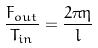<formula> <loc_0><loc_0><loc_500><loc_500>\frac { F _ { o u t } } { T _ { i n } } = \frac { 2 \pi \eta } { l }</formula> 